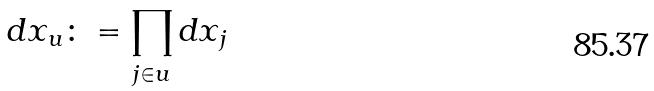Convert formula to latex. <formula><loc_0><loc_0><loc_500><loc_500>d x _ { u } \colon = \prod _ { j \in u } d x _ { j }</formula> 